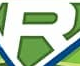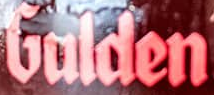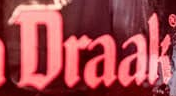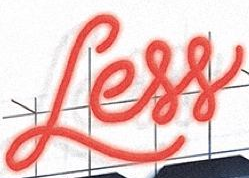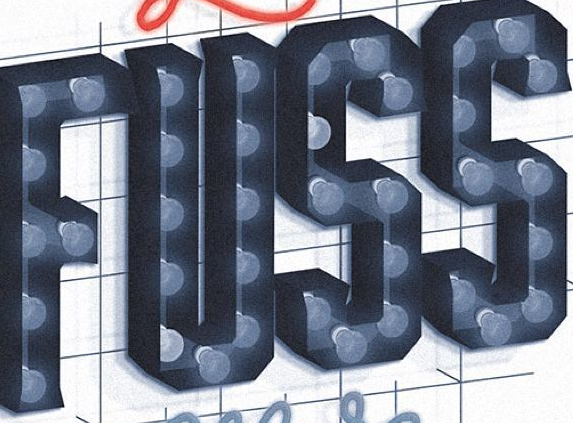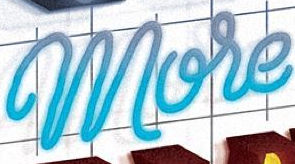What words are shown in these images in order, separated by a semicolon? R; Gulden; Draak; Less; FUSS; More 